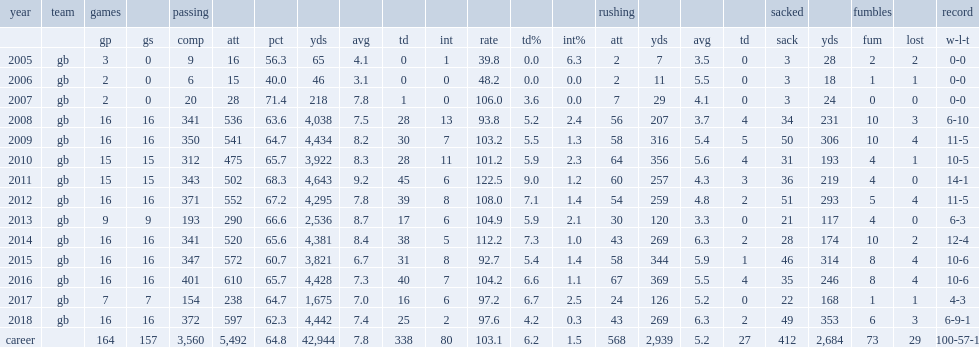How many passing yards did aaron rodgers have? 3821.0. 